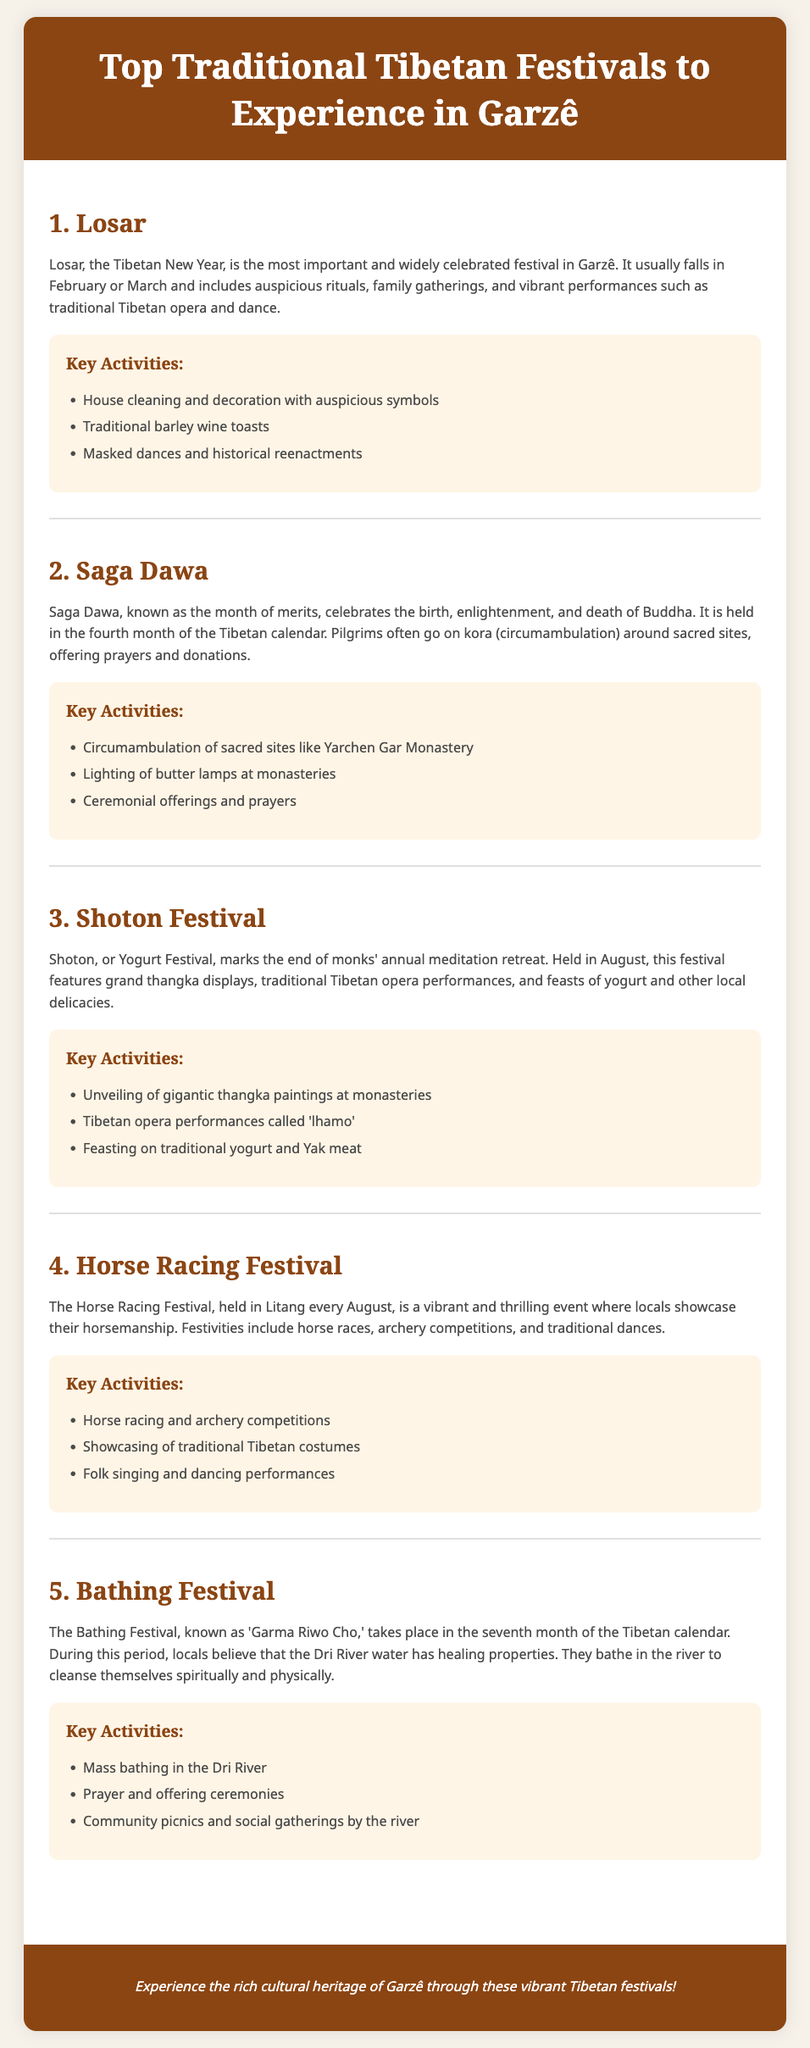what is the most important Tibetan festival in Garzê? The most important festival mentioned in the document is Losar, which is celebrated widely in Garzê.
Answer: Losar when is the Horse Racing Festival held? The Horse Racing Festival takes place in August, specifically noted in the document as occurring every August in Litang.
Answer: August what traditional performance is featured during Shoton Festival? The document states that Tibetan opera performances called 'lhamo' are featured during the Shoton Festival.
Answer: lhamo how many key activities are listed for the Bathing Festival? The Bathing Festival includes three key activities mentioned in the document.
Answer: 3 what month of the Tibetan calendar does Saga Dawa occur? Saga Dawa is held in the fourth month of the Tibetan calendar, as indicated in the document.
Answer: fourth month what is the significance of the Dri River during the Bathing Festival? The document explains that the locals believe the Dri River water has healing properties during the Bathing Festival.
Answer: healing properties which festival involves circumambulation of sacred sites? The document mentions that Saga Dawa involves circumambulation of sacred sites.
Answer: Saga Dawa what type of food is celebrated during Shoton Festival? The document mentions that yogurt is celebrated during the Shoton Festival, alongside other local delicacies.
Answer: yogurt 